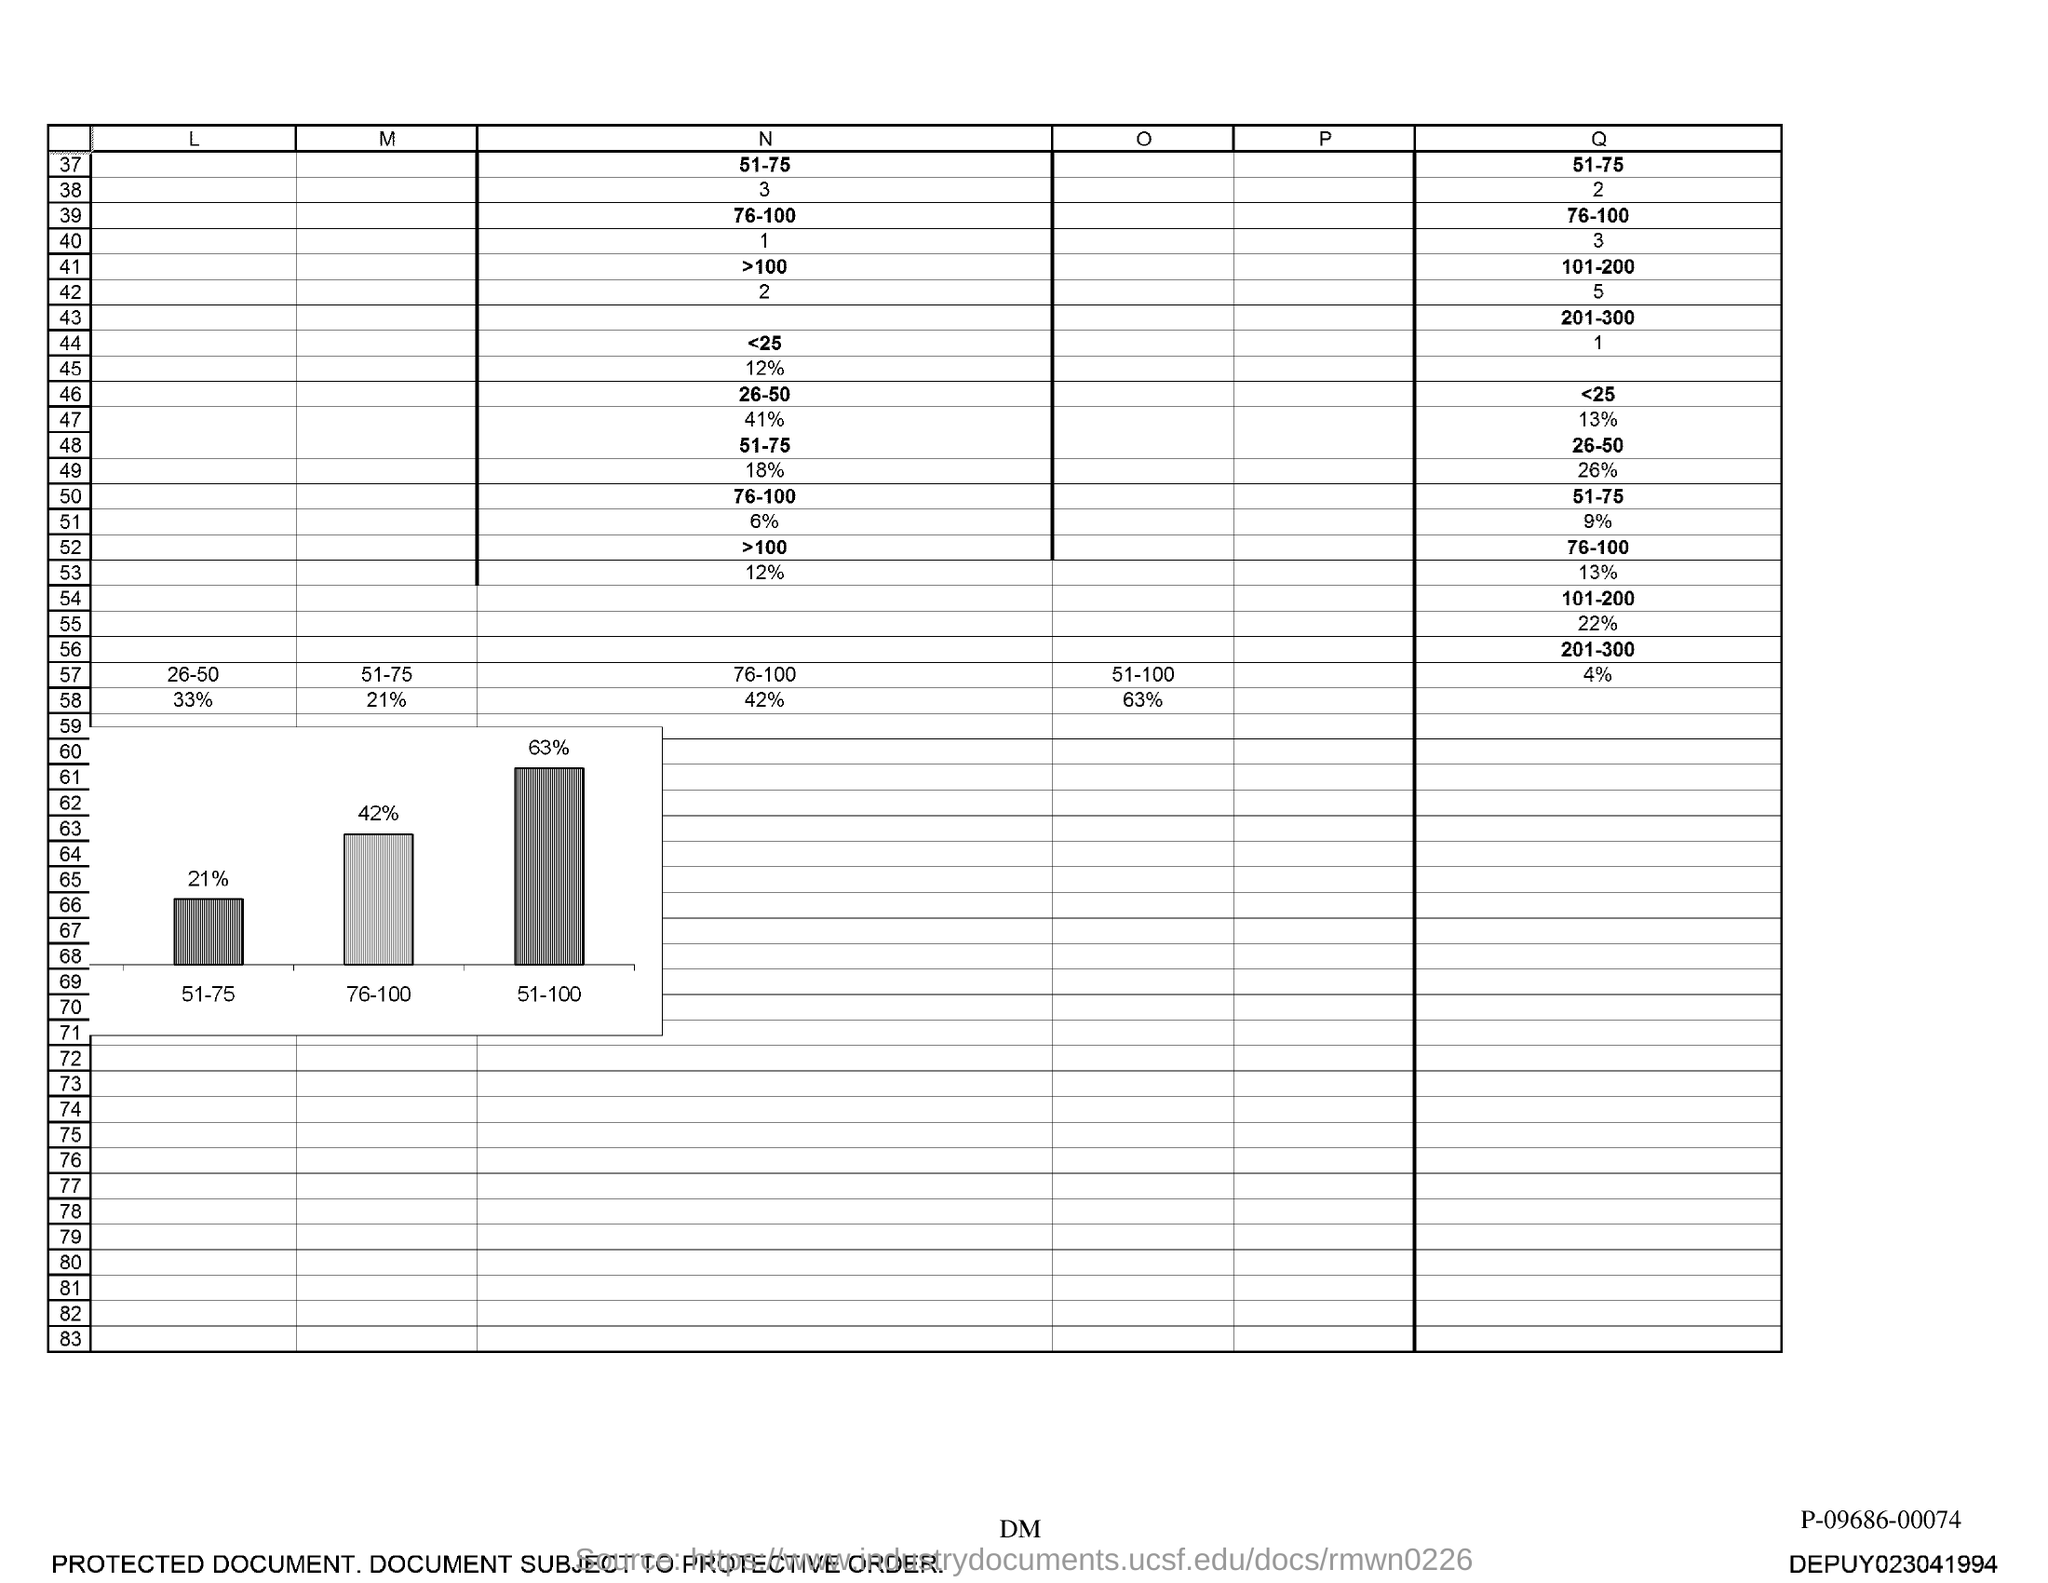Point out several critical features in this image. The range of N associated with the number 37 is 51 to 75. 